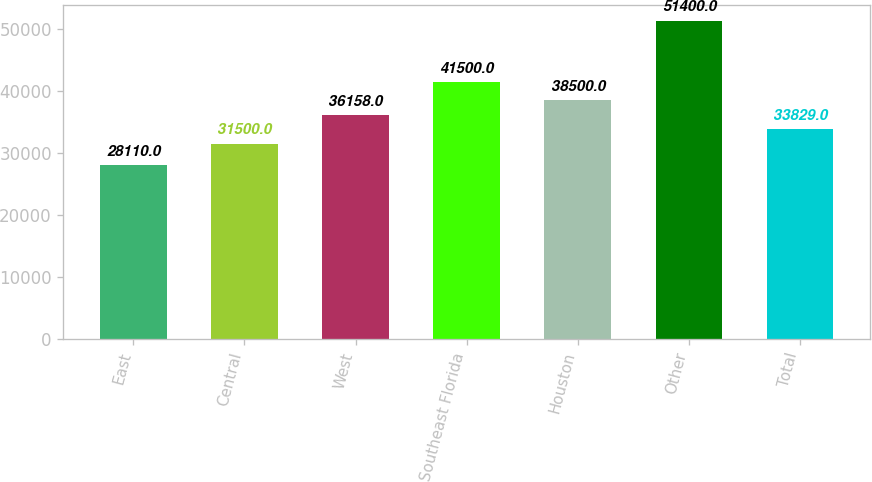Convert chart to OTSL. <chart><loc_0><loc_0><loc_500><loc_500><bar_chart><fcel>East<fcel>Central<fcel>West<fcel>Southeast Florida<fcel>Houston<fcel>Other<fcel>Total<nl><fcel>28110<fcel>31500<fcel>36158<fcel>41500<fcel>38500<fcel>51400<fcel>33829<nl></chart> 